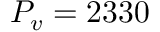<formula> <loc_0><loc_0><loc_500><loc_500>P _ { v } = 2 3 3 0</formula> 